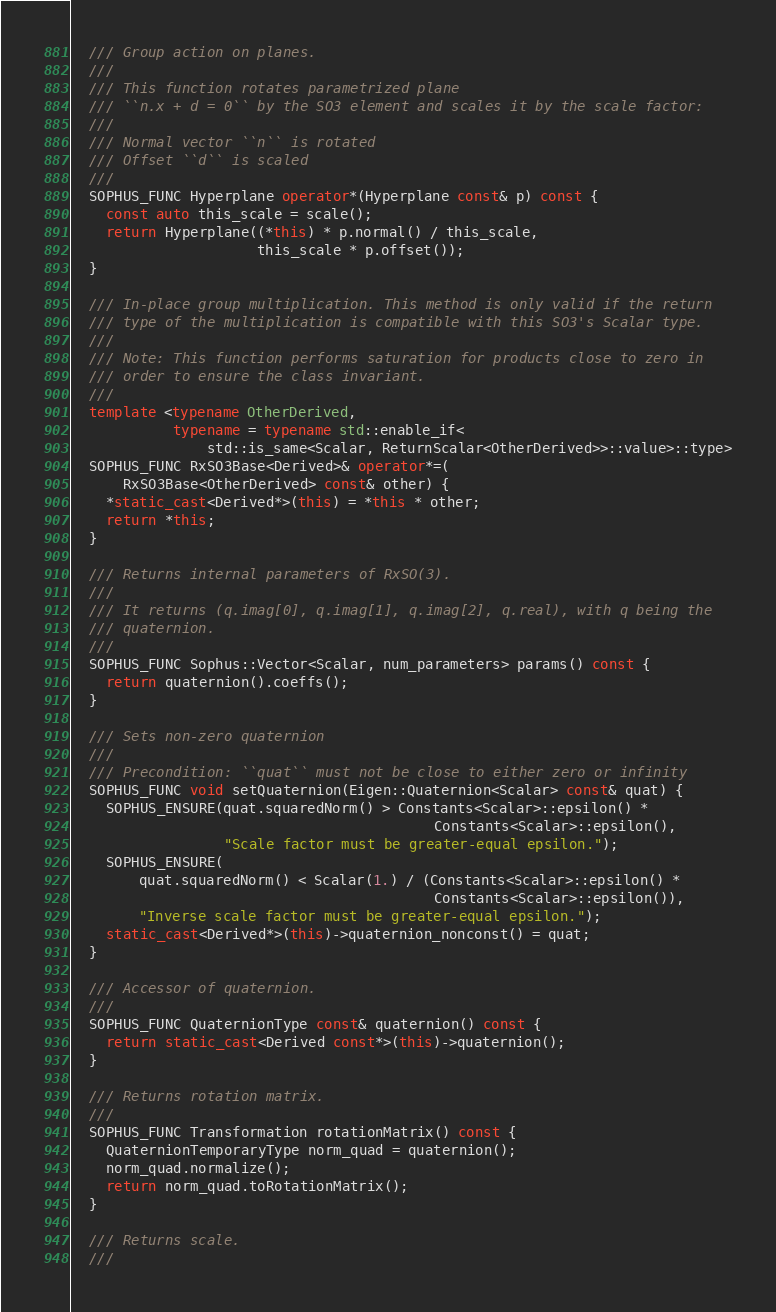Convert code to text. <code><loc_0><loc_0><loc_500><loc_500><_C++_>
  /// Group action on planes.
  ///
  /// This function rotates parametrized plane
  /// ``n.x + d = 0`` by the SO3 element and scales it by the scale factor:
  ///
  /// Normal vector ``n`` is rotated
  /// Offset ``d`` is scaled
  ///
  SOPHUS_FUNC Hyperplane operator*(Hyperplane const& p) const {
    const auto this_scale = scale();
    return Hyperplane((*this) * p.normal() / this_scale,
                      this_scale * p.offset());
  }

  /// In-place group multiplication. This method is only valid if the return
  /// type of the multiplication is compatible with this SO3's Scalar type.
  ///
  /// Note: This function performs saturation for products close to zero in
  /// order to ensure the class invariant.
  ///
  template <typename OtherDerived,
            typename = typename std::enable_if<
                std::is_same<Scalar, ReturnScalar<OtherDerived>>::value>::type>
  SOPHUS_FUNC RxSO3Base<Derived>& operator*=(
      RxSO3Base<OtherDerived> const& other) {
    *static_cast<Derived*>(this) = *this * other;
    return *this;
  }

  /// Returns internal parameters of RxSO(3).
  ///
  /// It returns (q.imag[0], q.imag[1], q.imag[2], q.real), with q being the
  /// quaternion.
  ///
  SOPHUS_FUNC Sophus::Vector<Scalar, num_parameters> params() const {
    return quaternion().coeffs();
  }

  /// Sets non-zero quaternion
  ///
  /// Precondition: ``quat`` must not be close to either zero or infinity
  SOPHUS_FUNC void setQuaternion(Eigen::Quaternion<Scalar> const& quat) {
    SOPHUS_ENSURE(quat.squaredNorm() > Constants<Scalar>::epsilon() *
                                           Constants<Scalar>::epsilon(),
                  "Scale factor must be greater-equal epsilon.");
    SOPHUS_ENSURE(
        quat.squaredNorm() < Scalar(1.) / (Constants<Scalar>::epsilon() *
                                           Constants<Scalar>::epsilon()),
        "Inverse scale factor must be greater-equal epsilon.");
    static_cast<Derived*>(this)->quaternion_nonconst() = quat;
  }

  /// Accessor of quaternion.
  ///
  SOPHUS_FUNC QuaternionType const& quaternion() const {
    return static_cast<Derived const*>(this)->quaternion();
  }

  /// Returns rotation matrix.
  ///
  SOPHUS_FUNC Transformation rotationMatrix() const {
    QuaternionTemporaryType norm_quad = quaternion();
    norm_quad.normalize();
    return norm_quad.toRotationMatrix();
  }

  /// Returns scale.
  ///</code> 